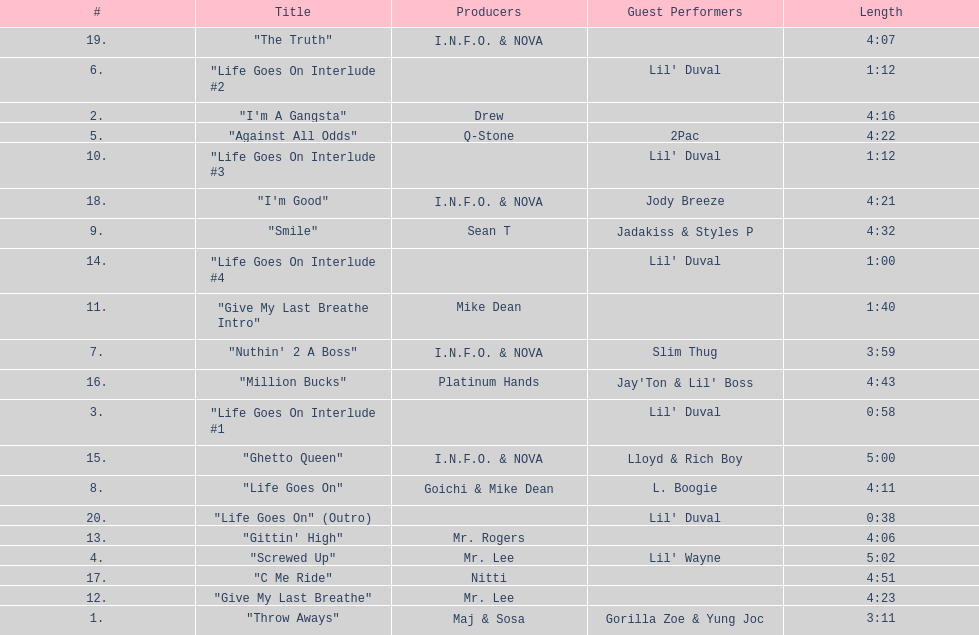Which producers produced the majority of songs on this record? I.N.F.O. & NOVA. 